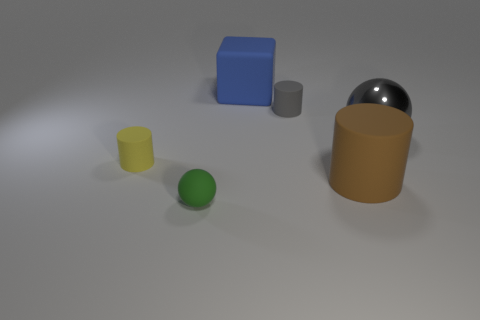Add 1 tiny gray rubber cylinders. How many objects exist? 7 Subtract all spheres. How many objects are left? 4 Subtract all yellow rubber spheres. Subtract all large metal things. How many objects are left? 5 Add 3 gray cylinders. How many gray cylinders are left? 4 Add 4 big cyan cubes. How many big cyan cubes exist? 4 Subtract 0 red balls. How many objects are left? 6 